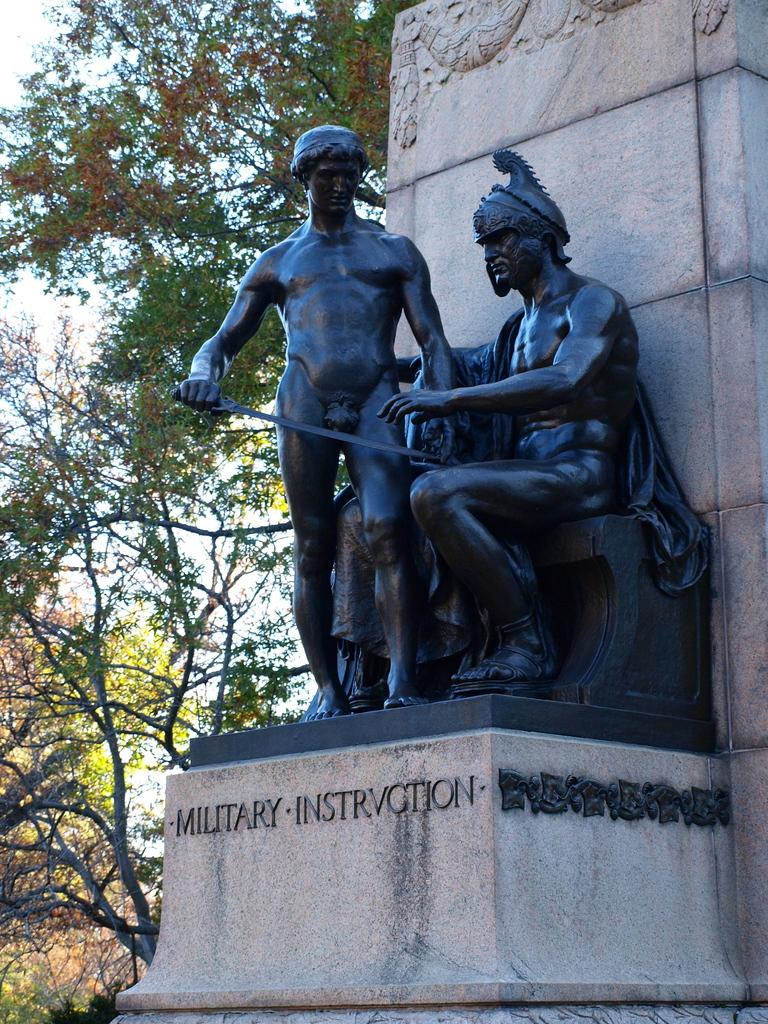What can be seen in the image that represents artistic creations? There are statues in the image. What is written or depicted on the statues? There is text on the surface of the statues. What type of natural environment is visible in the image? There are trees visible on the backside of the image. What is visible in the sky in the image? The sky is visible in the image. What type of cake is being served to the person wearing gloves and trousers in the image? There is no cake, person wearing gloves, or trousers present in the image. 